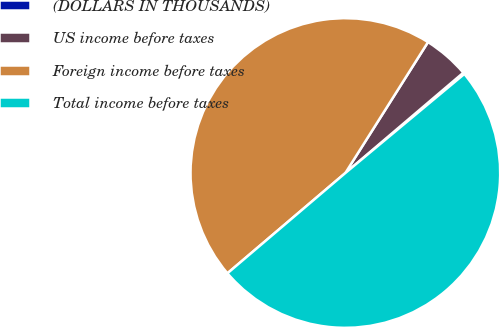Convert chart. <chart><loc_0><loc_0><loc_500><loc_500><pie_chart><fcel>(DOLLARS IN THOUSANDS)<fcel>US income before taxes<fcel>Foreign income before taxes<fcel>Total income before taxes<nl><fcel>0.17%<fcel>4.82%<fcel>45.18%<fcel>49.83%<nl></chart> 